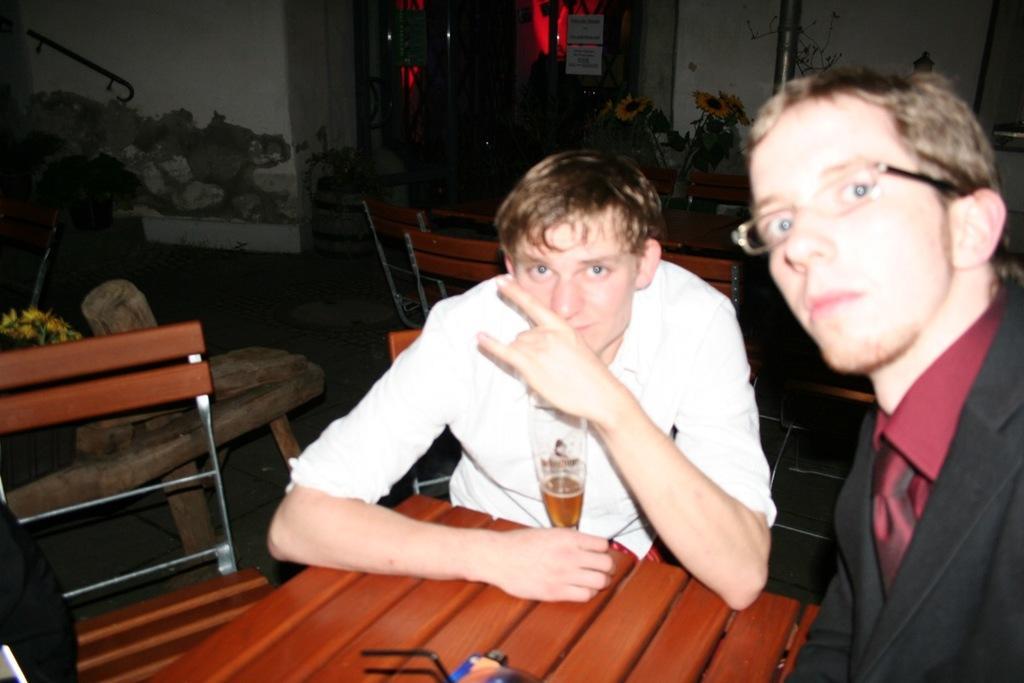Describe this image in one or two sentences. In the image we can see there are people who are sitting on chair and on table there is wine glass and the table is made up of wood and the person over here is wearing suit and spectacles and at the back there are flowers to the plant and the wall is in white colour. 